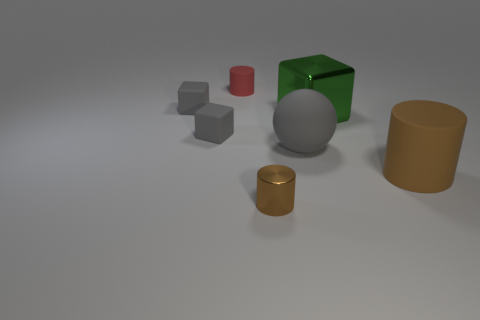Add 1 big cyan matte objects. How many objects exist? 8 Subtract all spheres. How many objects are left? 6 Subtract all small green cubes. Subtract all metallic cylinders. How many objects are left? 6 Add 2 red things. How many red things are left? 3 Add 3 large brown rubber cylinders. How many large brown rubber cylinders exist? 4 Subtract 0 purple blocks. How many objects are left? 7 